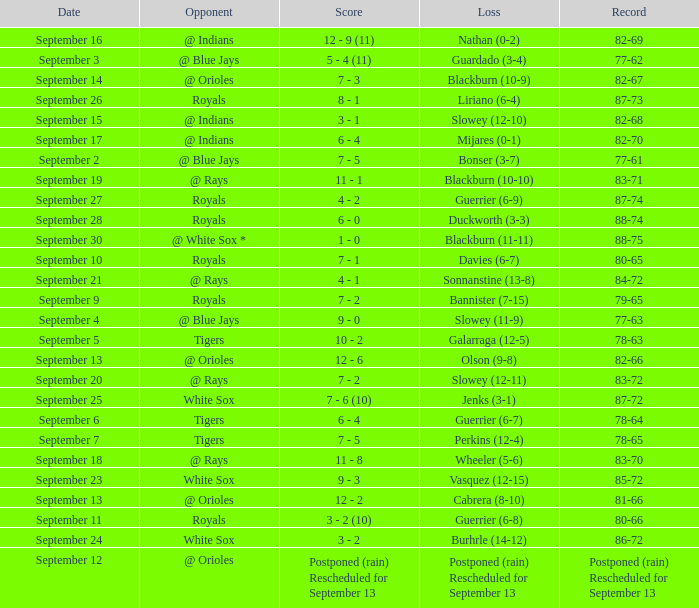What opponent has the record of 78-63? Tigers. 